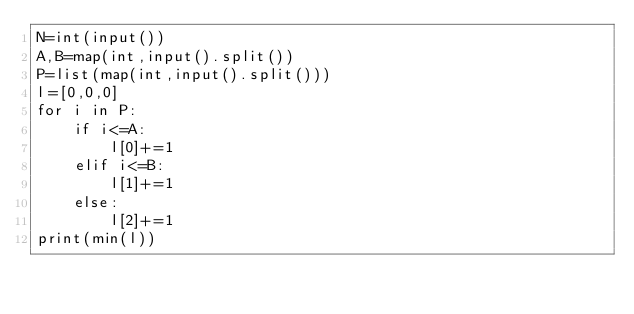Convert code to text. <code><loc_0><loc_0><loc_500><loc_500><_Python_>N=int(input())
A,B=map(int,input().split())
P=list(map(int,input().split()))
l=[0,0,0]
for i in P:
    if i<=A:
        l[0]+=1
    elif i<=B:
        l[1]+=1
    else:
        l[2]+=1
print(min(l))</code> 